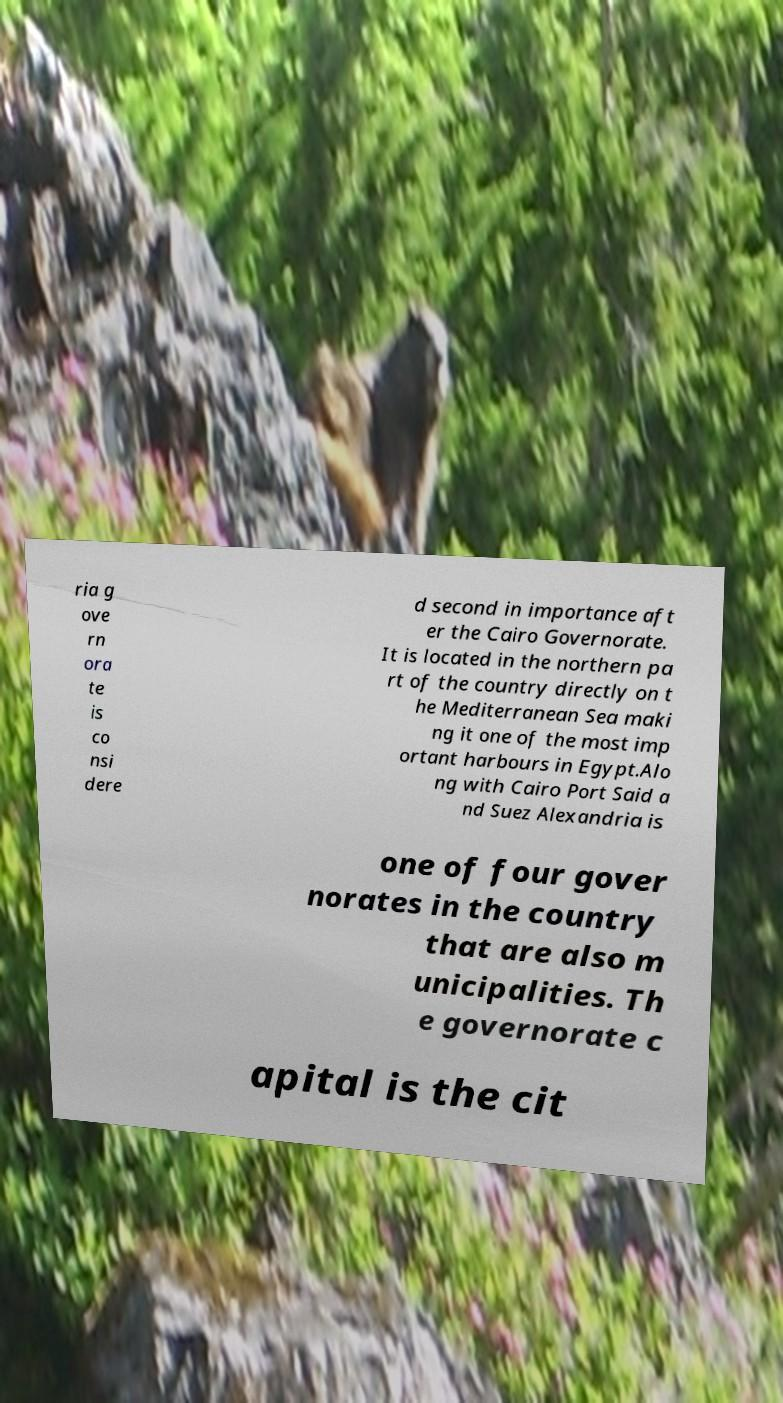Can you accurately transcribe the text from the provided image for me? ria g ove rn ora te is co nsi dere d second in importance aft er the Cairo Governorate. It is located in the northern pa rt of the country directly on t he Mediterranean Sea maki ng it one of the most imp ortant harbours in Egypt.Alo ng with Cairo Port Said a nd Suez Alexandria is one of four gover norates in the country that are also m unicipalities. Th e governorate c apital is the cit 